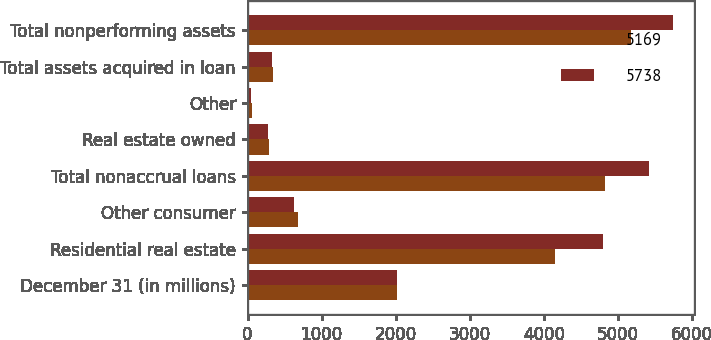Convert chart. <chart><loc_0><loc_0><loc_500><loc_500><stacked_bar_chart><ecel><fcel>December 31 (in millions)<fcel>Residential real estate<fcel>Other consumer<fcel>Total nonaccrual loans<fcel>Real estate owned<fcel>Other<fcel>Total assets acquired in loan<fcel>Total nonperforming assets<nl><fcel>5169<fcel>2016<fcel>4145<fcel>675<fcel>4820<fcel>292<fcel>57<fcel>349<fcel>5169<nl><fcel>5738<fcel>2015<fcel>4792<fcel>621<fcel>5413<fcel>277<fcel>48<fcel>325<fcel>5738<nl></chart> 